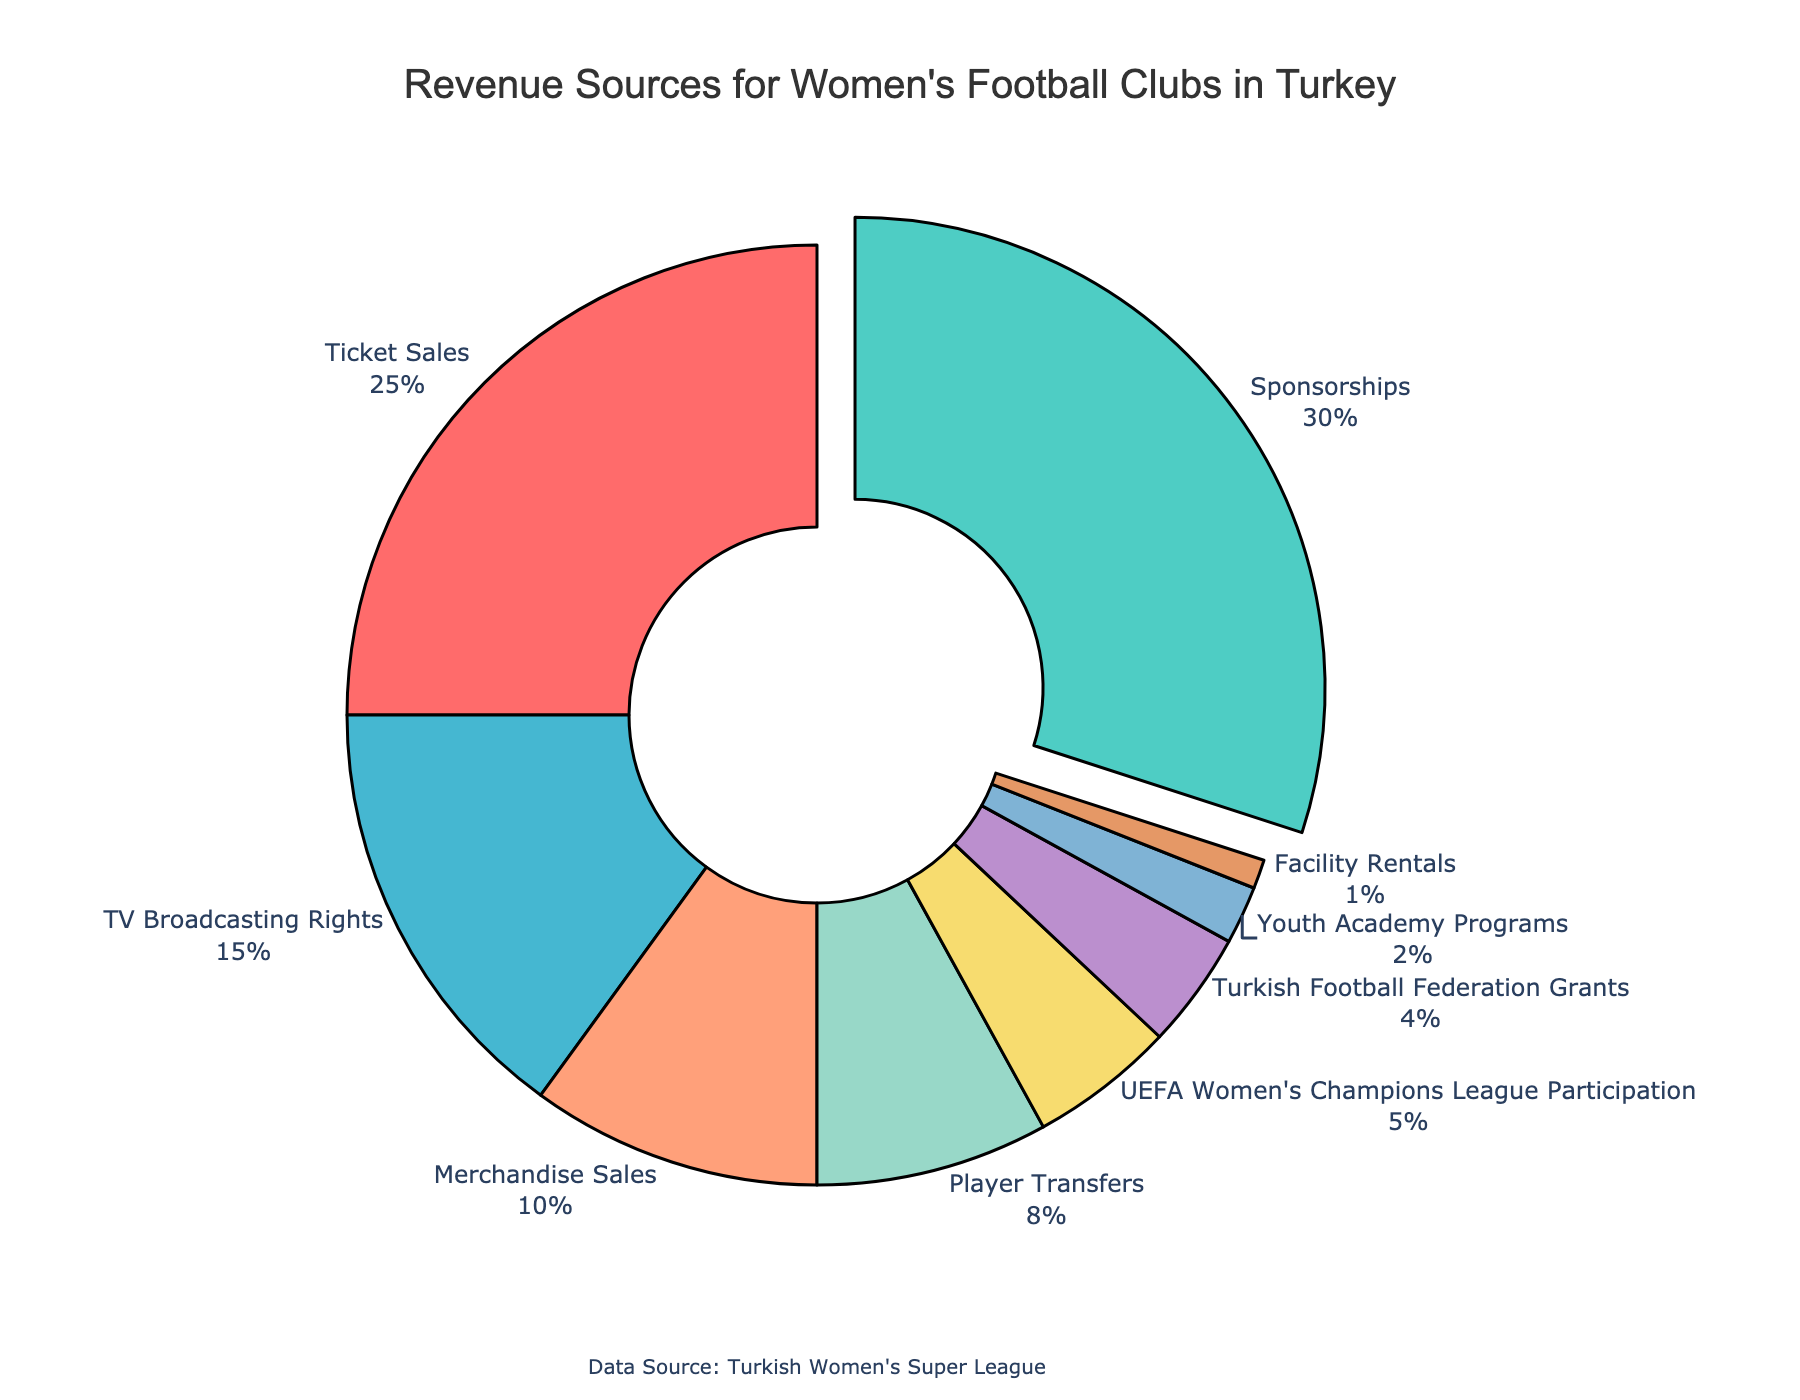Which revenue source contributes the highest percentage? The figure shows the percentages. By comparing the values, Sponsorships has the highest percentage at 30%.
Answer: Sponsorships What is the combined percentage of revenue from TV Broadcasting Rights and Merchandise Sales? Add the percentages of TV Broadcasting Rights (15%) and Merchandise Sales (10%) to get the combined percentage.
Answer: 25% How much higher is the percentage from Ticket Sales compared to Player Transfers? Subtract the percentage of Player Transfers (8%) from Ticket Sales (25%). 25% - 8% = 17%.
Answer: 17% Which sources have a percentage lower than 5%? Identify the revenue sources with percentages less than 5%. Turkish Football Federation Grants (4%), Youth Academy Programs (2%), and Facility Rentals (1%) meet this criterion.
Answer: Turkish Football Federation Grants, Youth Academy Programs, Facility Rentals What fraction of the total revenue is generated from UEFA Women's Champions League Participation? UEFA Women's Champions League Participation contributes 5% of the total revenue. In fraction form, this is 5/100 or 1/20.
Answer: 1/20 Which revenue sources are represented by shades of blue? In the chart, the colors of TV Broadcasting Rights and Merchandise Sales are shades of blue.
Answer: TV Broadcasting Rights, Merchandise Sales How does the revenue from Ticket Sales compare to the combined revenue of Player Transfers and Turkish Football Federation Grants? First, calculate the combined percentage of Player Transfers (8%) and Turkish Football Federation Grants (4%), which equals 12%. Then compare it to Ticket Sales (25%). Ticket Sales exceed the combined percentage.
Answer: Higher Is the percentage from Youth Academy Programs higher than Facility Rentals? Youth Academy Programs (2%) is higher than Facility Rentals (1%).
Answer: Yes If we combine the percentage from Sponsorships and UEFA Women's Champions League Participation, what part of the chart will this cover in total? Sponsorships contribute 30% and UEFA Women's Champions League Participation contributes 5%. Summing these yields a total of 35%.
Answer: 35% What is the visual indicator of the highest contributing revenue source? The highest contributing revenue source, Sponsorships, is visually indicated by being pulled slightly outward from the rest of the pie chart slices.
Answer: Pulled outward pie slice 